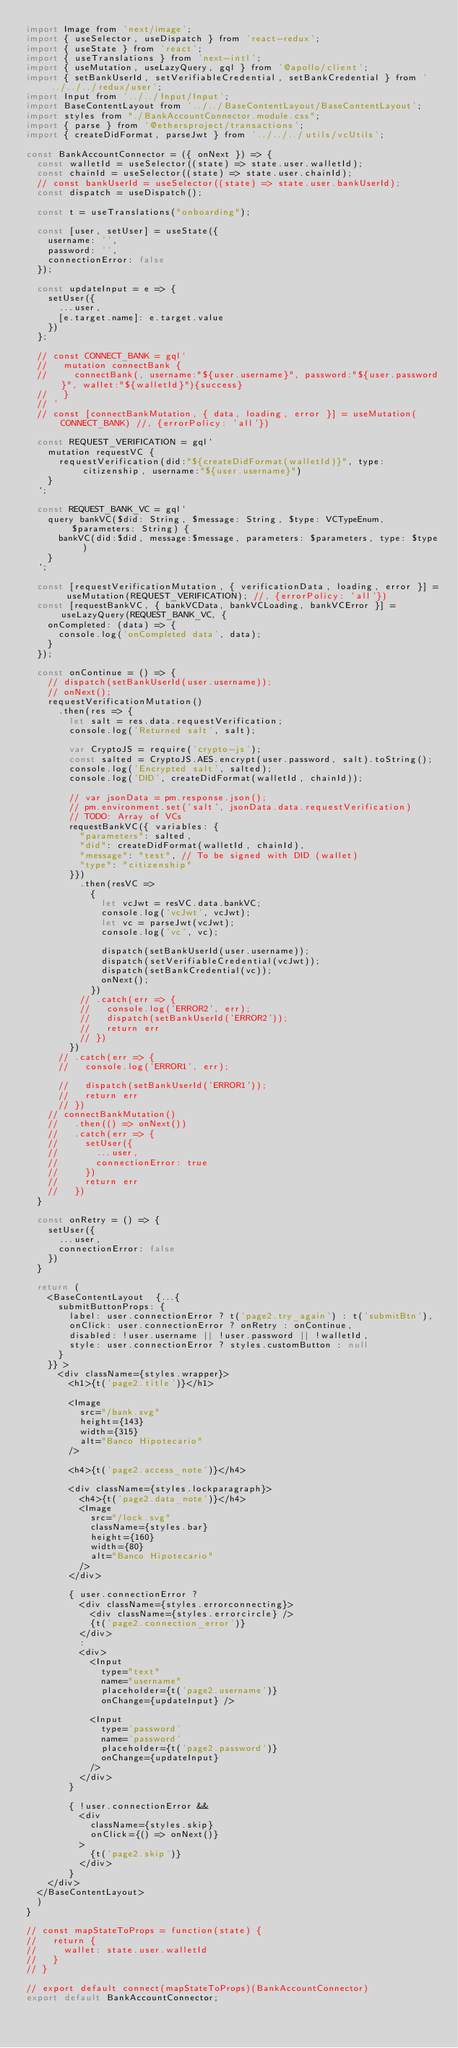Convert code to text. <code><loc_0><loc_0><loc_500><loc_500><_JavaScript_>import Image from 'next/image';
import { useSelector, useDispatch } from 'react-redux';
import { useState } from 'react';
import { useTranslations } from 'next-intl';
import { useMutation, useLazyQuery, gql } from '@apollo/client';
import { setBankUserId, setVerifiableCredential, setBankCredential } from '../../../redux/user';
import Input from '../../Input/Input';
import BaseContentLayout from '../../BaseContentLayout/BaseContentLayout';
import styles from "./BankAccountConnector.module.css";
import { parse } from '@ethersproject/transactions';
import { createDidFormat, parseJwt } from '../../../utils/vcUtils';

const BankAccountConnector = ({ onNext }) => {
  const walletId = useSelector((state) => state.user.walletId);
  const chainId = useSelector((state) => state.user.chainId);
  // const bankUserId = useSelector((state) => state.user.bankUserId);
  const dispatch = useDispatch();

  const t = useTranslations("onboarding");

  const [user, setUser] = useState({
    username: '',
    password: '',
    connectionError: false
  });

  const updateInput = e => {
    setUser({
      ...user,
      [e.target.name]: e.target.value
    })
  };

  // const CONNECT_BANK = gql`
  //   mutation connectBank {
  //     connectBank(, username:"${user.username}", password:"${user.password}", wallet:"${walletId}"){success}
  //   }
  // `
  // const [connectBankMutation, { data, loading, error }] = useMutation(CONNECT_BANK) //, {errorPolicy: 'all'})

  const REQUEST_VERIFICATION = gql`
    mutation requestVC {
      requestVerification(did:"${createDidFormat(walletId)}", type:citizenship, username:"${user.username}")
    }  
  `;

  const REQUEST_BANK_VC = gql`
    query bankVC($did: String, $message: String, $type: VCTypeEnum, $parameters: String) {
      bankVC(did:$did, message:$message, parameters: $parameters, type: $type)
    }
  `;

  const [requestVerificationMutation, { verificationData, loading, error }] = useMutation(REQUEST_VERIFICATION); //, {errorPolicy: 'all'})
  const [requestBankVC, { bankVCData, bankVCLoading, bankVCError }] = useLazyQuery(REQUEST_BANK_VC, {
    onCompleted: (data) => {
      console.log('onCompleted data', data);
    }    
  });

  const onContinue = () => {
    // dispatch(setBankUserId(user.username));
    // onNext();
    requestVerificationMutation()
      .then(res => {
        let salt = res.data.requestVerification;
        console.log('Returned salt', salt);

        var CryptoJS = require('crypto-js');
        const salted = CryptoJS.AES.encrypt(user.password, salt).toString();
        console.log('Encrypted salt', salted);
        console.log('DID', createDidFormat(walletId, chainId));

        // var jsonData = pm.response.json();
        // pm.environment.set('salt', jsonData.data.requestVerification)
        // TODO: Array of VCs
        requestBankVC({ variables: {
          "parameters": salted,
          "did": createDidFormat(walletId, chainId),
          "message": "test", // To be signed with DID (wallet)
          "type": "citizenship"
        }})
          .then(resVC =>
            {
              let vcJwt = resVC.data.bankVC;
              console.log('vcJwt', vcJwt);
              let vc = parseJwt(vcJwt);
              console.log('vc', vc);
              
              dispatch(setBankUserId(user.username));
              dispatch(setVerifiableCredential(vcJwt));
              dispatch(setBankCredential(vc));
              onNext();
            })
          // .catch(err => {
          //   console.log('ERROR2', err);
          //   dispatch(setBankUserId('ERROR2'));
          //   return err
          // })
        })
      // .catch(err => {
      //   console.log('ERROR1', err);

      //   dispatch(setBankUserId('ERROR1'));
      //   return err
      // })
    // connectBankMutation()
    //   .then(() => onNext())
    //   .catch(err => {
    //     setUser({
    //       ...user,
    //       connectionError: true
    //     })
    //     return err
    //   })
  }

  const onRetry = () => {
    setUser({
      ...user,
      connectionError: false
    })
  }

  return (
    <BaseContentLayout  {...{
      submitButtonProps: {
        label: user.connectionError ? t('page2.try_again') : t('submitBtn'),
        onClick: user.connectionError ? onRetry : onContinue,
        disabled: !user.username || !user.password || !walletId,
        style: user.connectionError ? styles.customButton : null
      }
    }} >
      <div className={styles.wrapper}>
        <h1>{t('page2.title')}</h1>

        <Image
          src="/bank.svg"
          height={143}
          width={315}
          alt="Banco Hipotecario"
        />

        <h4>{t('page2.access_note')}</h4>

        <div className={styles.lockparagraph}>
          <h4>{t('page2.data_note')}</h4>
          <Image
            src="/lock.svg"
            className={styles.bar}
            height={160}
            width={80}
            alt="Banco Hipotecario"
          />
        </div>

        { user.connectionError ? 
          <div className={styles.errorconnecting}>
            <div className={styles.errorcircle} />
            {t('page2.connection_error')}
          </div>
          : 
          <div>
            <Input
              type="text"
              name="username"
              placeholder={t('page2.username')}
              onChange={updateInput} />

            <Input
              type='password'
              name='password'
              placeholder={t('page2.password')}
              onChange={updateInput}
            />
          </div>
        }

        { !user.connectionError &&
          <div
            className={styles.skip}
            onClick={() => onNext()}
          >
            {t('page2.skip')}
          </div>
        }
    </div> 
  </BaseContentLayout>
  )
}

// const mapStateToProps = function(state) {
//   return {
//     wallet: state.user.walletId
//   }
// }

// export default connect(mapStateToProps)(BankAccountConnector)
export default BankAccountConnector;</code> 